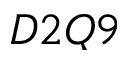Convert formula to latex. <formula><loc_0><loc_0><loc_500><loc_500>D 2 Q 9</formula> 